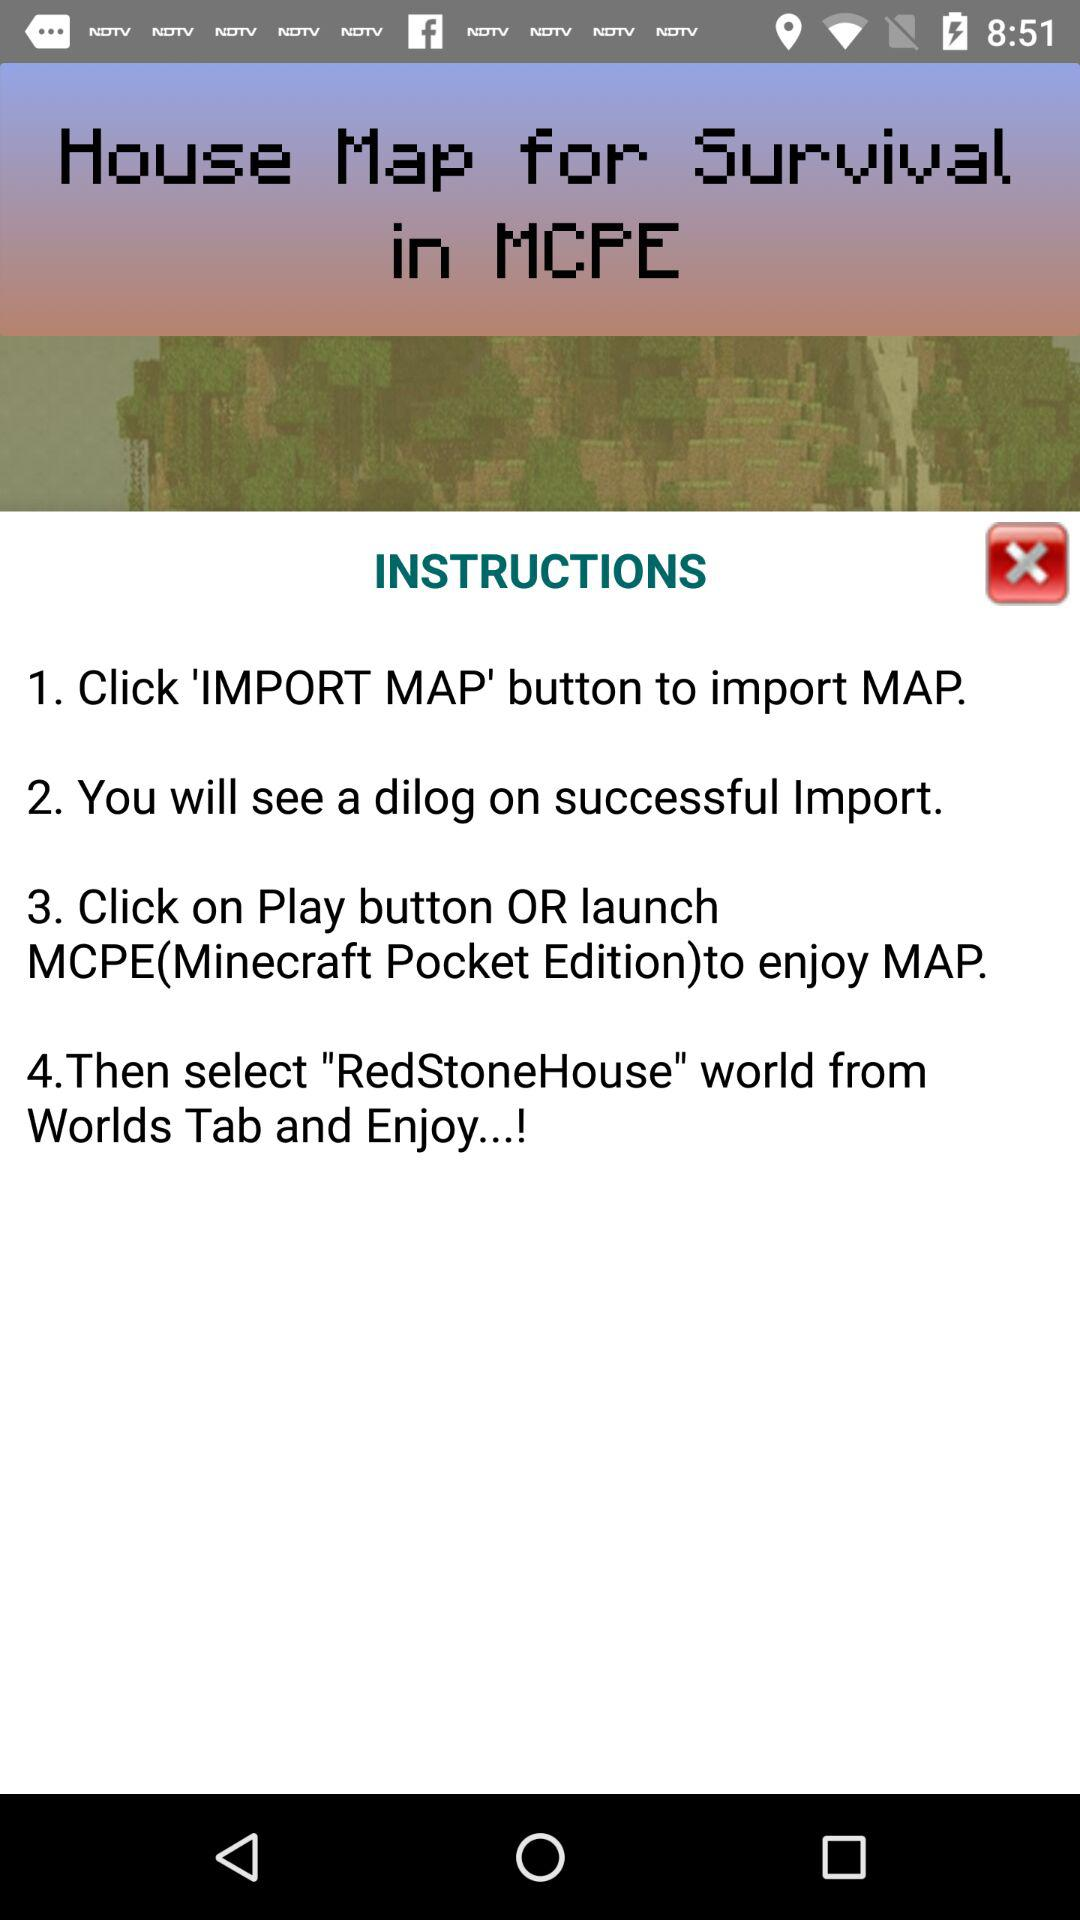How many steps are there in the instructions?
Answer the question using a single word or phrase. 4 